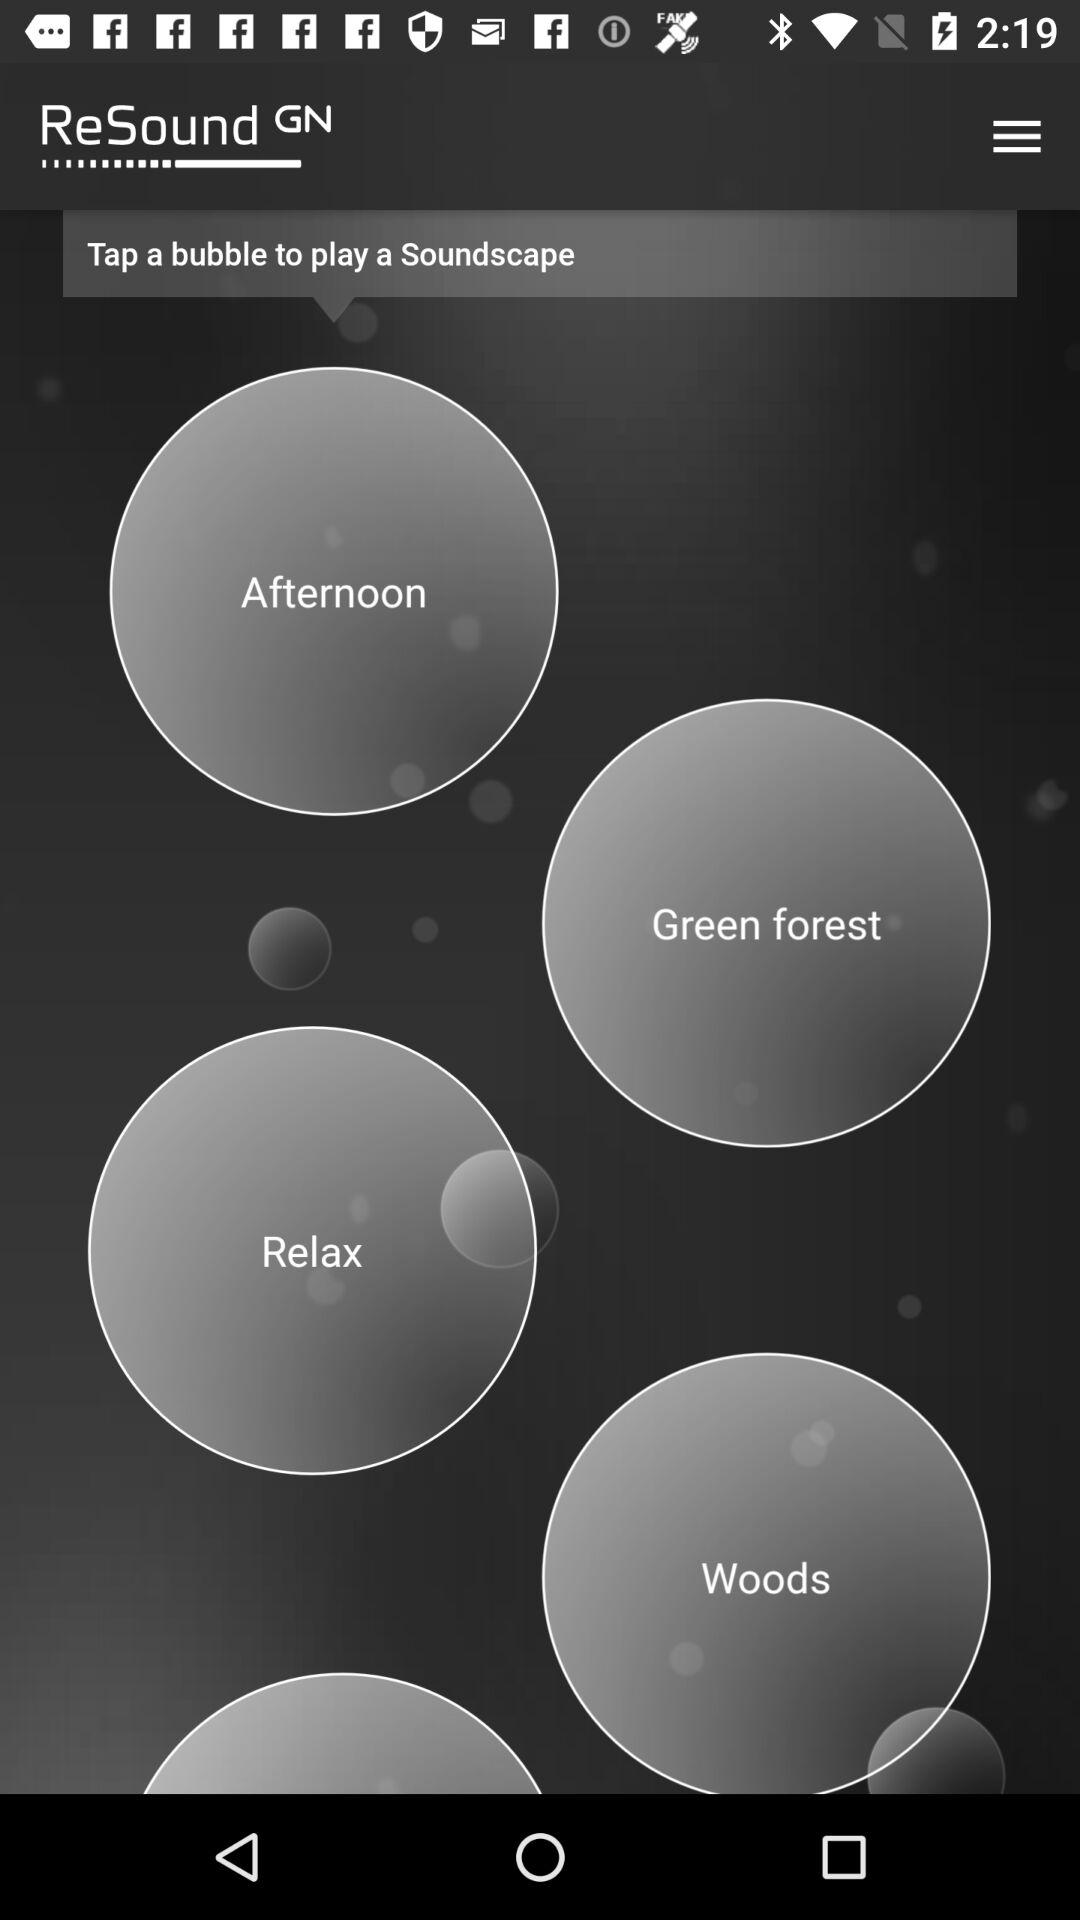What is the name of the application? The name of the application is "ReSound". 